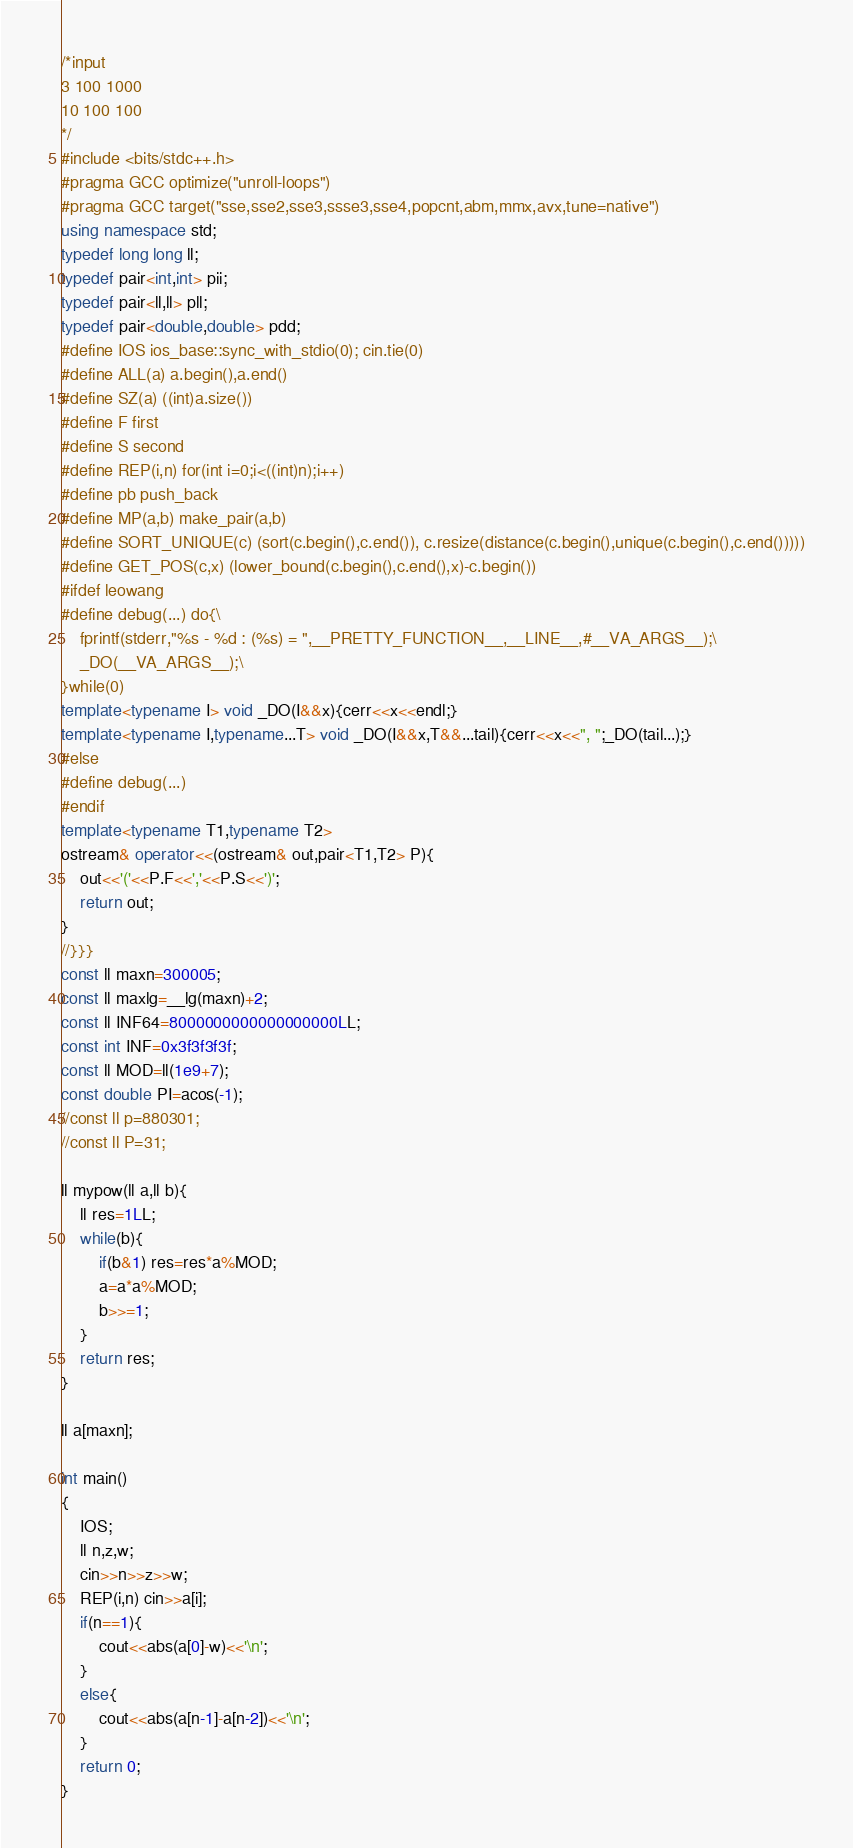Convert code to text. <code><loc_0><loc_0><loc_500><loc_500><_C++_>/*input
3 100 1000
10 100 100
*/
#include <bits/stdc++.h>
#pragma GCC optimize("unroll-loops")
#pragma GCC target("sse,sse2,sse3,ssse3,sse4,popcnt,abm,mmx,avx,tune=native")
using namespace std;
typedef long long ll;
typedef pair<int,int> pii;
typedef pair<ll,ll> pll;
typedef pair<double,double> pdd;
#define IOS ios_base::sync_with_stdio(0); cin.tie(0)
#define ALL(a) a.begin(),a.end()
#define SZ(a) ((int)a.size())
#define F first
#define S second
#define REP(i,n) for(int i=0;i<((int)n);i++)
#define pb push_back
#define MP(a,b) make_pair(a,b)
#define SORT_UNIQUE(c) (sort(c.begin(),c.end()), c.resize(distance(c.begin(),unique(c.begin(),c.end()))))
#define GET_POS(c,x) (lower_bound(c.begin(),c.end(),x)-c.begin())
#ifdef leowang
#define debug(...) do{\
	fprintf(stderr,"%s - %d : (%s) = ",__PRETTY_FUNCTION__,__LINE__,#__VA_ARGS__);\
	_DO(__VA_ARGS__);\
}while(0)
template<typename I> void _DO(I&&x){cerr<<x<<endl;}
template<typename I,typename...T> void _DO(I&&x,T&&...tail){cerr<<x<<", ";_DO(tail...);}
#else
#define debug(...)
#endif
template<typename T1,typename T2>
ostream& operator<<(ostream& out,pair<T1,T2> P){
	out<<'('<<P.F<<','<<P.S<<')';
	return out;
}
//}}}
const ll maxn=300005;
const ll maxlg=__lg(maxn)+2;
const ll INF64=8000000000000000000LL;
const int INF=0x3f3f3f3f;
const ll MOD=ll(1e9+7);
const double PI=acos(-1);
//const ll p=880301;
//const ll P=31;

ll mypow(ll a,ll b){
	ll res=1LL;
	while(b){
		if(b&1) res=res*a%MOD;
		a=a*a%MOD;
		b>>=1;
	}
	return res;
}

ll a[maxn];

int main()
{
	IOS;
	ll n,z,w;
	cin>>n>>z>>w;
	REP(i,n) cin>>a[i];
	if(n==1){
		cout<<abs(a[0]-w)<<'\n';
	}
	else{
		cout<<abs(a[n-1]-a[n-2])<<'\n';
	}
	return 0;
}
</code> 